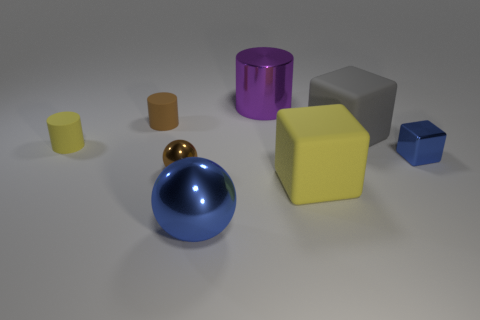The rubber thing that is both behind the large yellow rubber block and to the right of the brown matte object is what color?
Give a very brief answer. Gray. Does the yellow thing on the left side of the brown cylinder have the same size as the large purple metal object?
Offer a terse response. No. There is a tiny matte thing behind the yellow cylinder; is there a brown object left of it?
Ensure brevity in your answer.  No. What is the material of the blue block?
Make the answer very short. Metal. Are there any cubes left of the purple metal object?
Your answer should be very brief. No. The purple metal thing that is the same shape as the brown matte object is what size?
Provide a short and direct response. Large. Are there the same number of yellow blocks that are behind the small metal sphere and yellow objects in front of the large yellow thing?
Offer a very short reply. Yes. What number of gray blocks are there?
Ensure brevity in your answer.  1. Is the number of small brown cylinders on the right side of the purple cylinder greater than the number of big matte things?
Make the answer very short. No. There is a cube to the right of the big gray rubber object; what is its material?
Your answer should be very brief. Metal. 